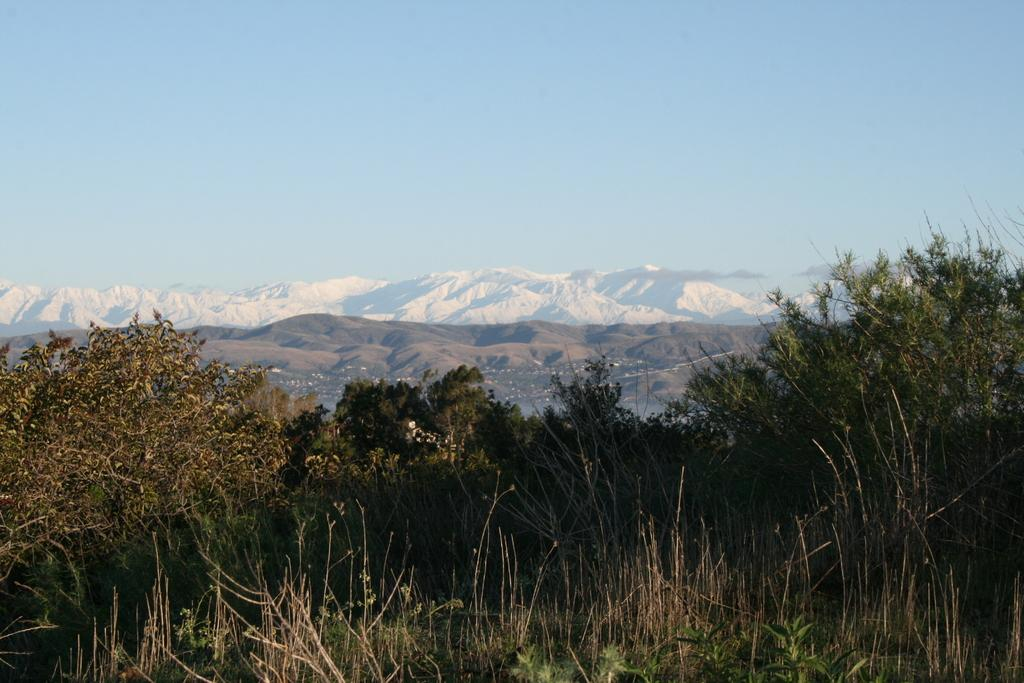What type of vegetation can be seen in the image? There are plants and trees in the image. What natural features are visible in the background of the image? There are mountains and the sky visible in the background of the image. Reasoning: Let' Let's think step by step in order to produce the conversation. We start by identifying the main subjects in the image, which are the plants and trees. Then, we expand the conversation to include the natural features visible in the background, such as the mountains and the sky. Each question is designed to elicit a specific detail about the image that is known from the provided facts. Absurd Question/Answer: Can you see an ant carrying a bite from the ocean in the image? There is no ant or ocean present in the image, so it is not possible to see an ant carrying a bite from the ocean. 